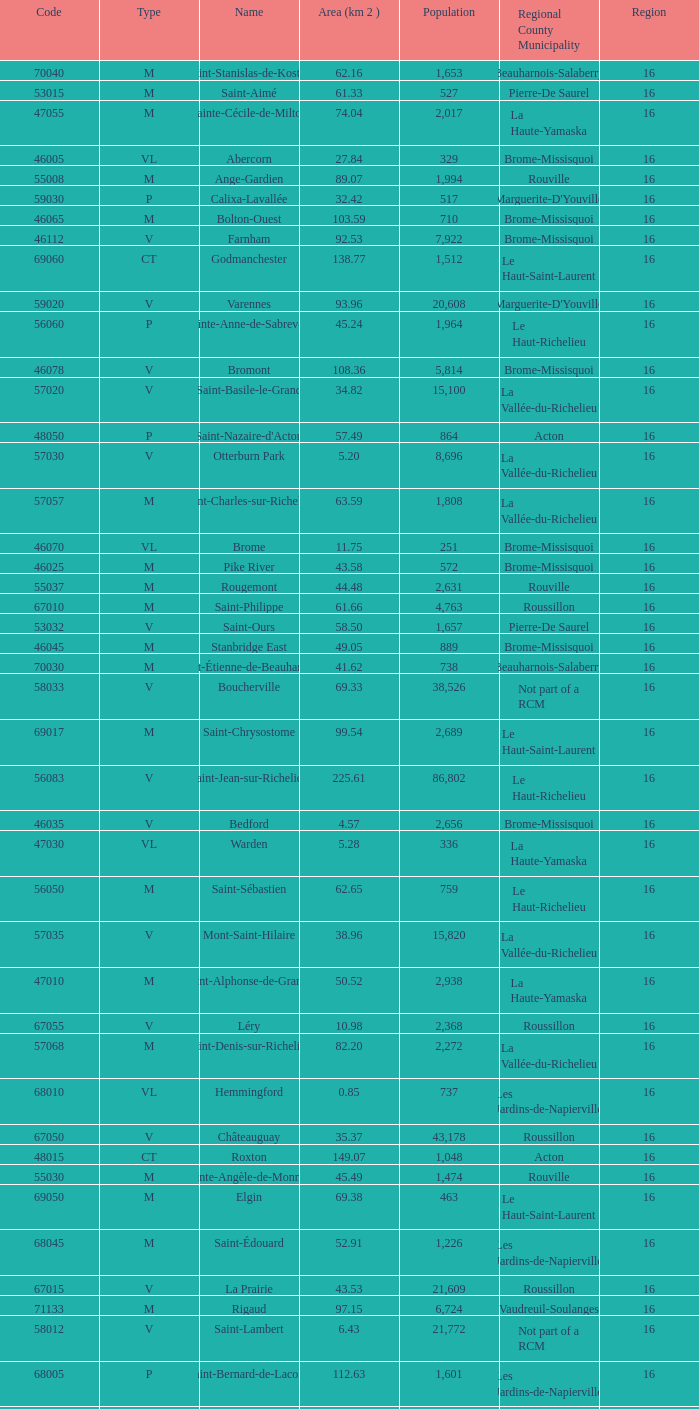Saint-Blaise-Sur-Richelieu is smaller than 68.42 km^2, what is the population of this type M municipality? None. 